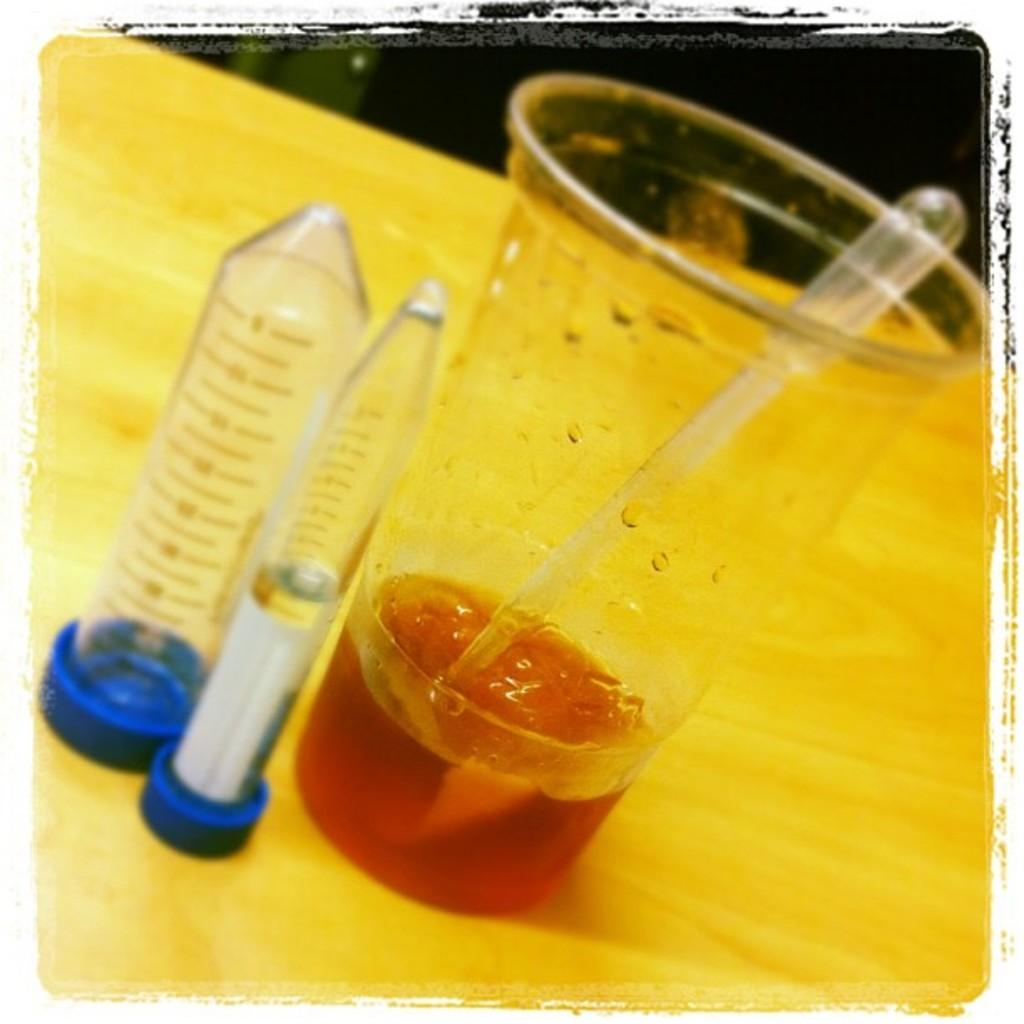What is present on the table in the image? There is a glass on the table in the image. What is inside the glass? The glass contains some liquid and a filler. Are there any other items related to the glass in the image? Yes, there are two small test tubes beside the glass. What type of quilt is used to cover the table in the image? There is no quilt present in the image; the table is not covered. How does the fork interact with the liquid in the glass in the image? There is no fork present in the image; the glass is not being used with a fork. 